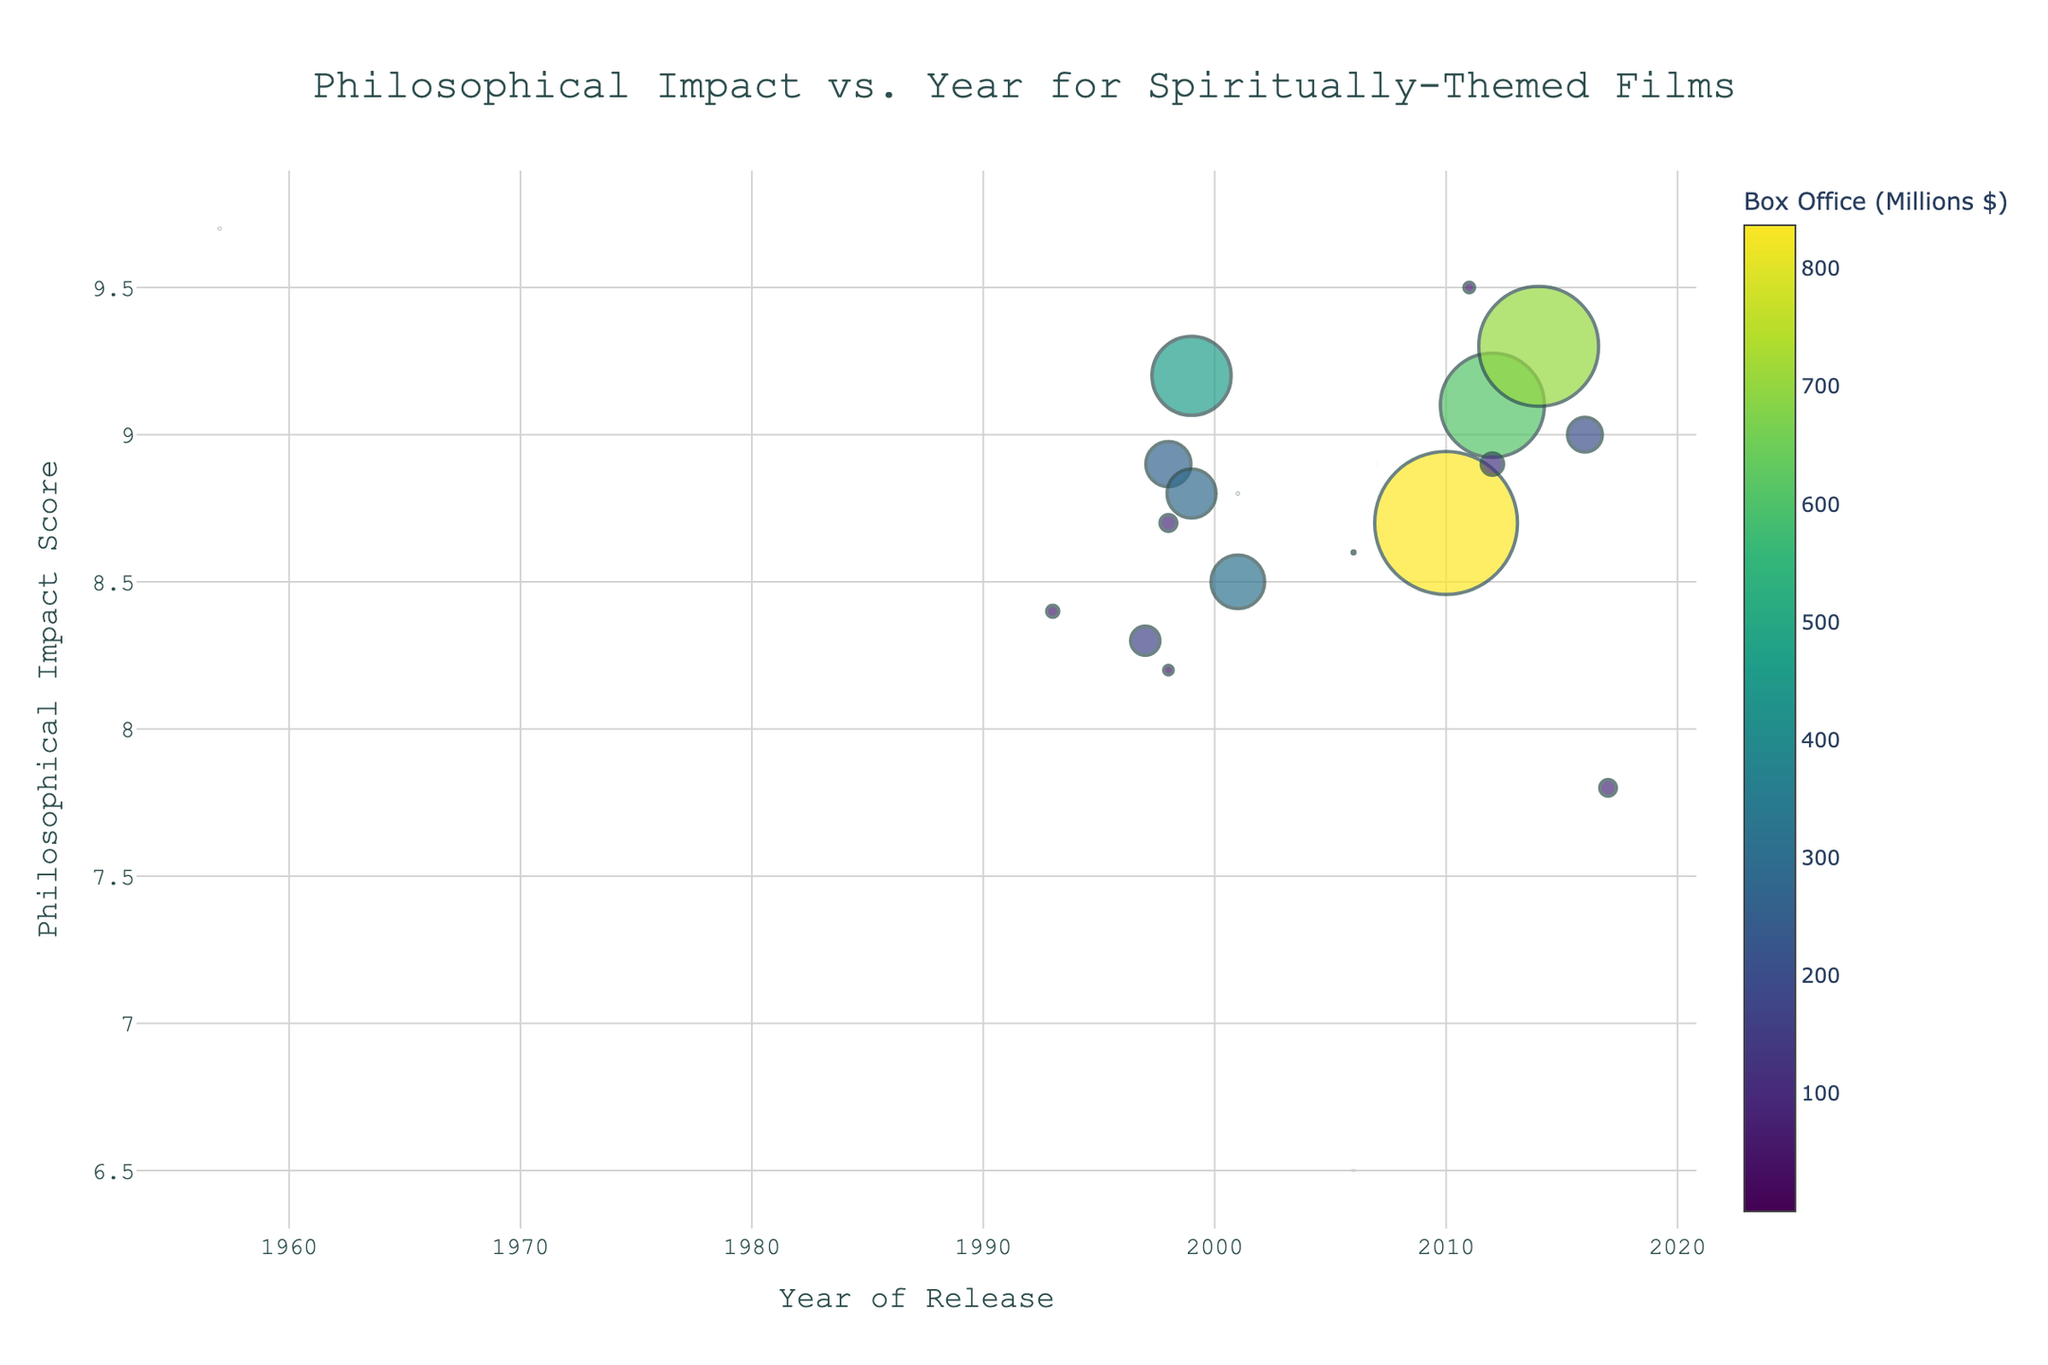how many films are plotted in the figure? To get the total number of films, count the number of distinct data points displayed on the plot.
Answer: 19 which movie has the highest philosophical impact score? Identify the data point with the highest y-value (Philosophical Impact Score) on the plot.
Answer: The Seventh Seal which movie made the highest box office revenue? Locate the largest marker (indicating the highest revenue) on the plot.
Answer: Inception which year features the movie with the lowest philosophical impact score? Identify the data point with the lowest y-value (Philosophical Impact Score) and check its corresponding year.
Answer: 2006 between 1999 and 2014, which year had the highest average philosophical impact score for movies? Calculate the average Philosophical Impact Score for the movies released in each year within this range, then identify which year has the highest average.
Answer: 1999 (since it has notable high scores and multiple entries) are there more movies with a philosophical impact score above 9.0 or below 8.0? Count the number of data points above 9.0 on the y-axis and compare it with the number of data points below 8.0 on the y-axis.
Answer: Above 9.0 which movie from the 2000s had the largest box office revenue? Look at the size of markers for movies released between 2000 and 2009 and identify the largest one.
Answer: A Beautiful Mind which film released after 2010 had the highest philosophical impact score? Check the data points for movies released after 2010 and identify the one with the highest y-value.
Answer: Interstellar which movie from the 1990s had both a high philosophical impact score and significant box office revenue? Find a marker from the 1990s that is both high on the y-axis and relatively large in size.
Answer: The Green Mile which year had the largest variability in philosophical impact scores? Assess the spread of y-values (philosophical impact scores) for each year and determine which year had data points most spread out.
Answer: 1998 